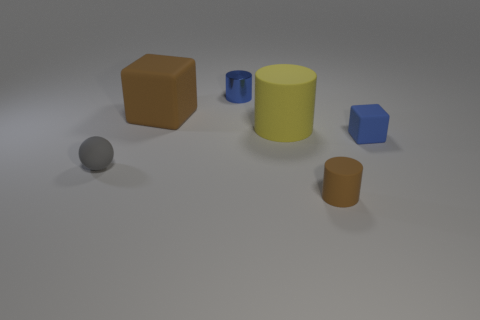Subtract all big cylinders. How many cylinders are left? 2 Add 2 small blue metal objects. How many objects exist? 8 Subtract all blue cylinders. How many cylinders are left? 2 Subtract all purple spheres. How many yellow cylinders are left? 1 Subtract all big red cubes. Subtract all spheres. How many objects are left? 5 Add 3 large rubber blocks. How many large rubber blocks are left? 4 Add 2 brown rubber things. How many brown rubber things exist? 4 Subtract 0 green cylinders. How many objects are left? 6 Subtract all cubes. How many objects are left? 4 Subtract 2 cubes. How many cubes are left? 0 